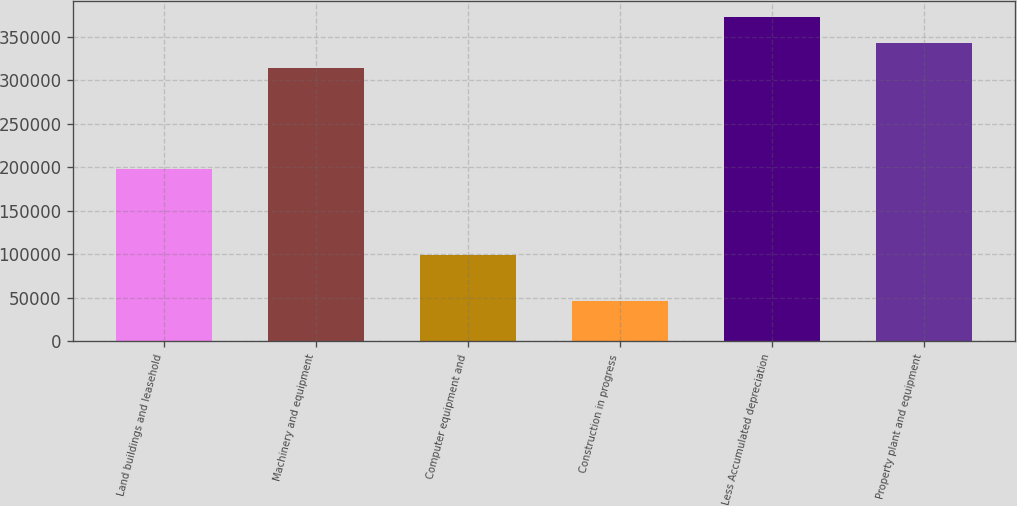<chart> <loc_0><loc_0><loc_500><loc_500><bar_chart><fcel>Land buildings and leasehold<fcel>Machinery and equipment<fcel>Computer equipment and<fcel>Construction in progress<fcel>Less Accumulated depreciation<fcel>Property plant and equipment<nl><fcel>197365<fcel>313404<fcel>99343<fcel>45945<fcel>372202<fcel>342803<nl></chart> 